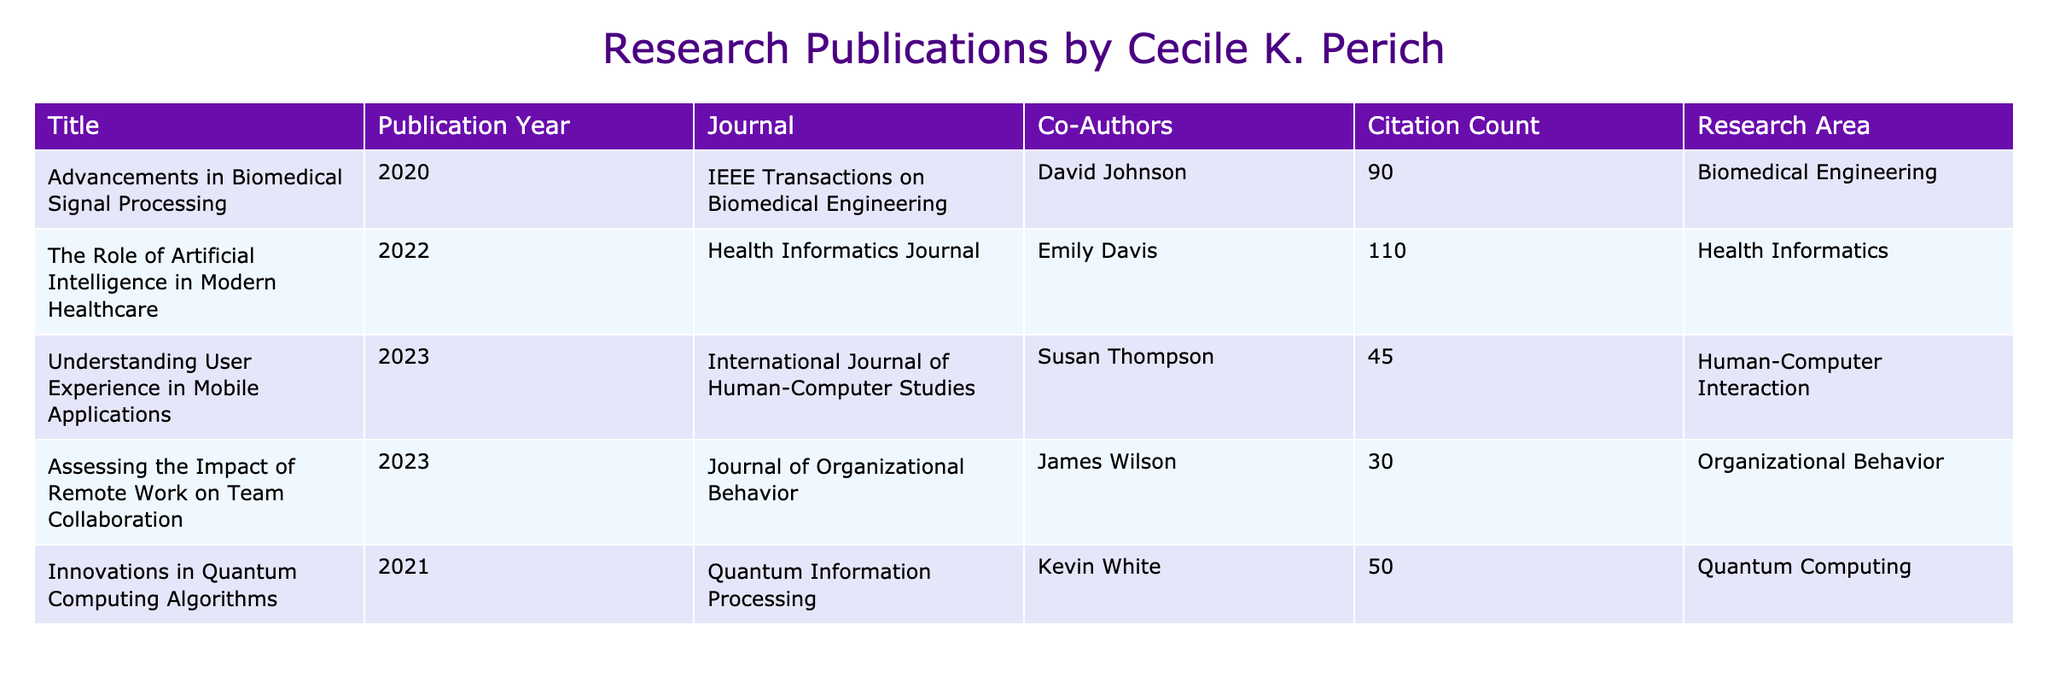What is the title of the highest cited publication? The highest cited publication can be found by looking at the citation counts for each publication. The maximum citation count is 110, which corresponds to the title "The Role of Artificial Intelligence in Modern Healthcare."
Answer: "The Role of Artificial Intelligence in Modern Healthcare" Which journal published the research on "Assessing the Impact of Remote Work on Team Collaboration"? By locating the title "Assessing the Impact of Remote Work on Team Collaboration" in the table, we see that it corresponds to the journal "Journal of Organizational Behavior."
Answer: "Journal of Organizational Behavior" What is the average citation count of the publications authored or co-authored by Cecile K. Perich? To find the average, we sum all citation counts: (90 + 110 + 45 + 30 + 50) = 325. Then, we divide this sum by the number of publications (5), resulting in 325 / 5 = 65.
Answer: 65 How many publications have a citation count of 50 or more? We need to review the citation counts: 90, 110, 45, 30, 50. The counts that meet the criterion (50 or more) are 90, 110, and 50, which totals 3 publications.
Answer: 3 Is there any publication in the "Quantum Computing" research area? By checking the research areas provided, we see "Innovations in Quantum Computing Algorithms" is listed in the "Quantum Computing" area, confirming the existence of such a publication.
Answer: Yes Which publication year has the highest number of citations? We look through the publication years and their corresponding citation counts: 2020 (90), 2022 (110), 2023 (75), and 2021 (50). The highest citation count of 110 is from the year 2022.
Answer: 2022 What is the difference in citation count between the publication "Understanding User Experience in Mobile Applications" and the publication "Innovations in Quantum Computing Algorithms"? First, we identify their citation counts: "Understanding User Experience in Mobile Applications" has 45 citations, and "Innovations in Quantum Computing Algorithms" has 50 citations. The difference is 50 - 45 = 5.
Answer: 5 Which publication has the lowest citation count, and what is that count? By inspecting the citation counts, we identify that "Assessing the Impact of Remote Work on Team Collaboration" with a count of 30 citations is the lowest.
Answer: 30 In which research area is most of the work focused based on citation counts? We check the citation counts grouped by research area: Biomedical Engineering (90), Health Informatics (110), Human-Computer Interaction (45), Organizational Behavior (30), and Quantum Computing (50). The highest citation count is 110 in Health Informatics, indicating that's where most work is focused.
Answer: Health Informatics Are there any publications co-authored by more than one person? Reviewing the co-authors listed for each publication, all listed publications have a single co-author except for "The Role of Artificial Intelligence in Modern Healthcare", which is also co-authored. Therefore, there is at least one that fits this criterion.
Answer: Yes 